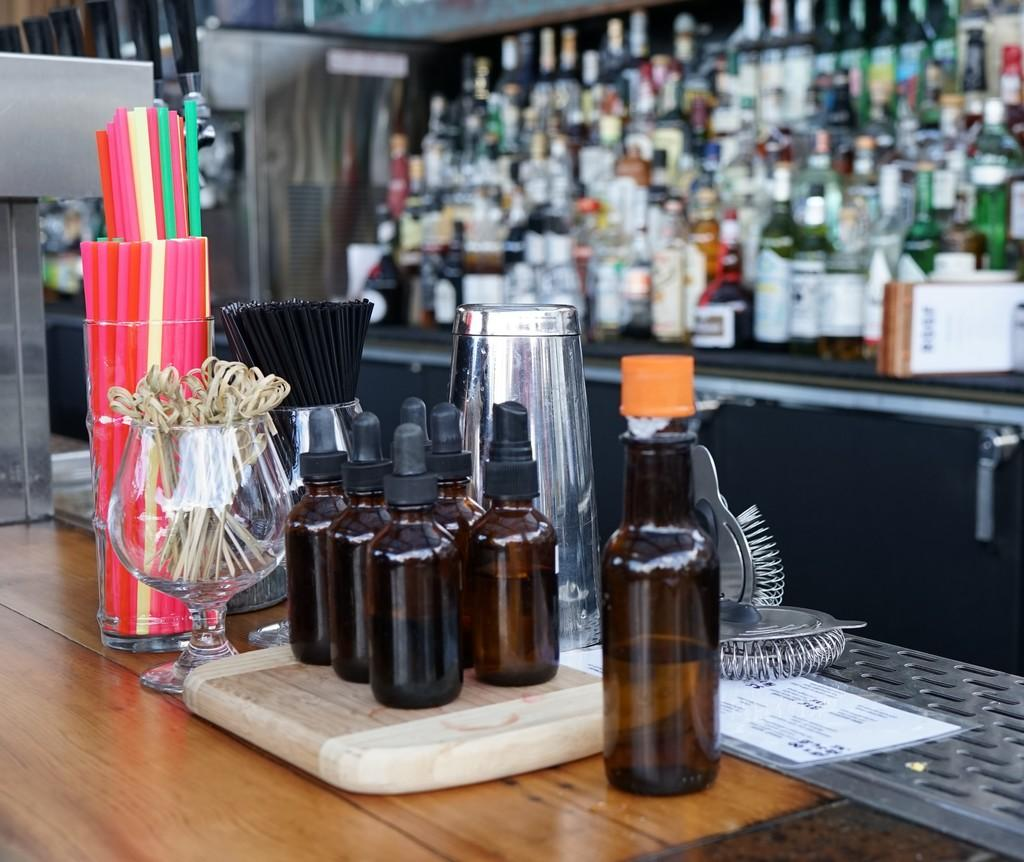What type of containers are on the table in the image? There are glass bottles on the table. What else can be seen on the table besides the glass bottles? There are other objects on the table. What type of beverage containers are visible in the background? There are wine bottles in the background. Where is the mailbox located in the image? There is no mailbox present in the image. What type of creatures can be seen swimming in the ocean in the image? There is no ocean present in the image. 